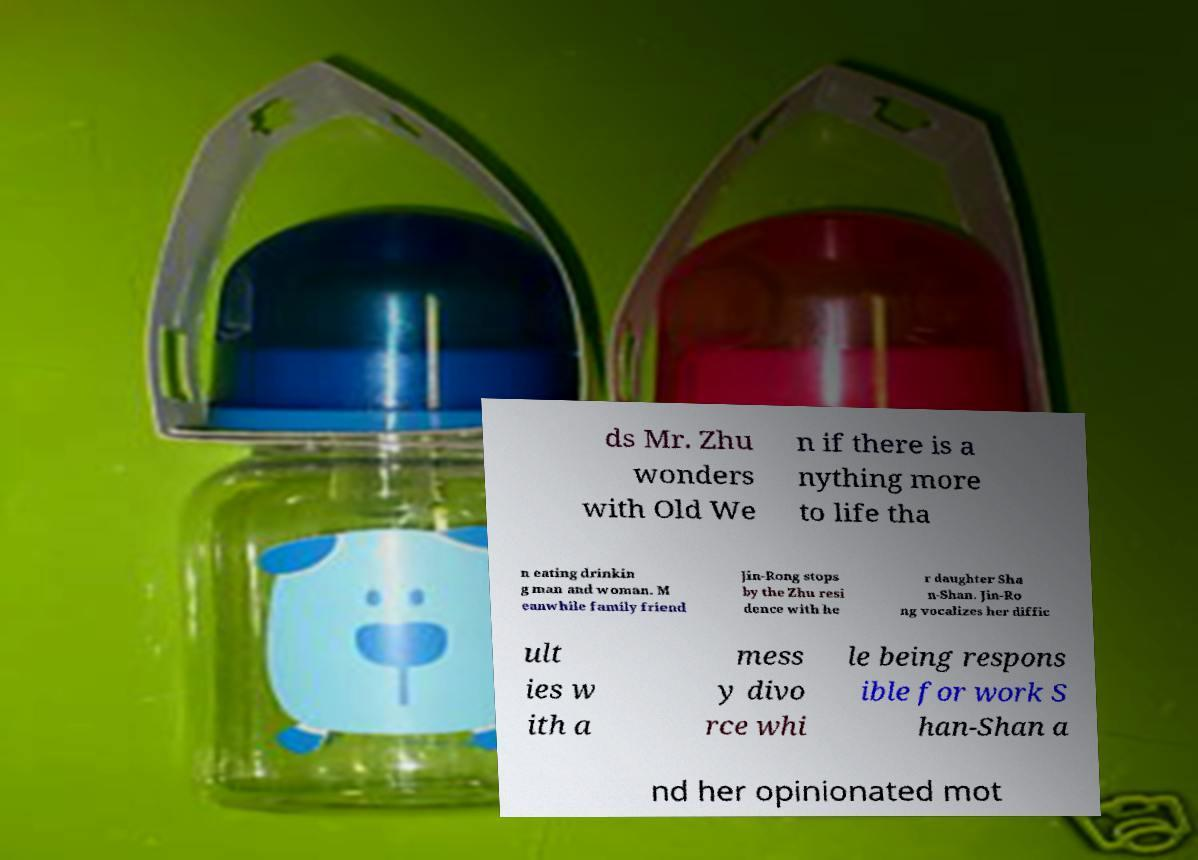I need the written content from this picture converted into text. Can you do that? ds Mr. Zhu wonders with Old We n if there is a nything more to life tha n eating drinkin g man and woman. M eanwhile family friend Jin-Rong stops by the Zhu resi dence with he r daughter Sha n-Shan. Jin-Ro ng vocalizes her diffic ult ies w ith a mess y divo rce whi le being respons ible for work S han-Shan a nd her opinionated mot 